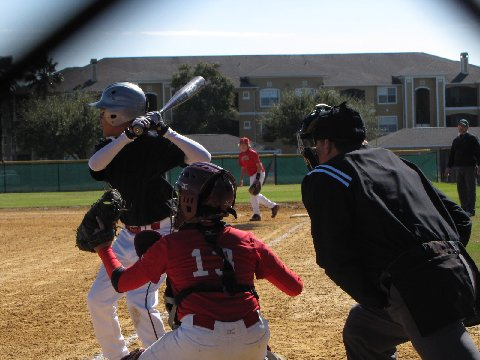<image>Who is winning the game? I am not sure who is winning the game. It can be the red team or the black team. Who is winning the game? I don't know who is winning the game. It can be either the red team or the black team. 